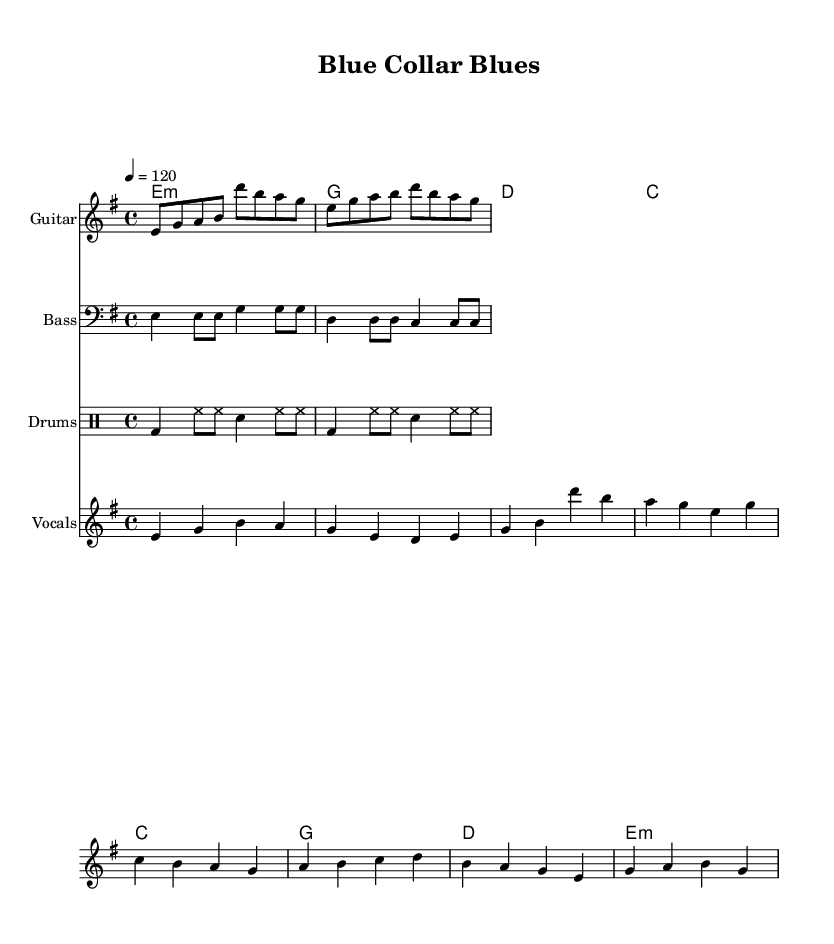What is the key signature of this music? The key signature is indicated at the beginning of the sheet music with sharps or flats. Here, it shows E minor, which has one sharp (F#).
Answer: E minor What is the time signature of the piece? The time signature is shown after the key signature at the beginning. It indicates how many beats are in a measure. This piece displays a 4/4 time signature, meaning there are four beats per measure.
Answer: 4/4 What is the tempo marking of this music? The tempo is notated at the start of the piece and is expressed in beats per minute. Here, it is set to 120, indicating a moderate pace.
Answer: 120 What instruments are used in this arrangement? The instruments can be identified by their labels above each staff. This arrangement includes Guitar, Bass, Drums, and Vocals.
Answer: Guitar, Bass, Drums, Vocals How many sections does the song have based on the structure? The song is divided into verses and choruses. The verse section has its own distinct melody, followed by the chorus with a different melody. Specifically, there are two verse sections followed by two chorus sections, making it a total of four sections.
Answer: Four Which line contains the lyrics for the verse? The lyrics for the verse are directly tied to the melody markings. In this case, the lyrics are notated just below the melody notes for the verse, which corresponds to the line 'VerseWords.'
Answer: VerseWords What type of lyrical theme does this song represent? The lyrics reference working-class struggles, as indicated by phrases relating to factory work and economic difficulties, highlighting a common theme found in classic rock music of that era.
Answer: Working-class struggles 